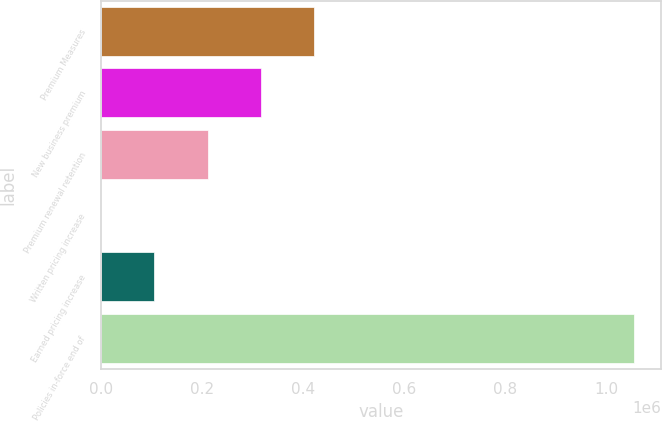<chart> <loc_0><loc_0><loc_500><loc_500><bar_chart><fcel>Premium Measures<fcel>New business premium<fcel>Premium renewal retention<fcel>Written pricing increase<fcel>Earned pricing increase<fcel>Policies in-force end of<nl><fcel>422186<fcel>316640<fcel>211094<fcel>2<fcel>105548<fcel>1.05546e+06<nl></chart> 